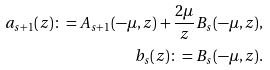<formula> <loc_0><loc_0><loc_500><loc_500>a _ { s + 1 } ( z ) \colon = A _ { s + 1 } ( - \mu , z ) + \frac { 2 \mu } { z } B _ { s } ( - \mu , z ) , \\ b _ { s } ( z ) \colon = B _ { s } ( - \mu , z ) .</formula> 